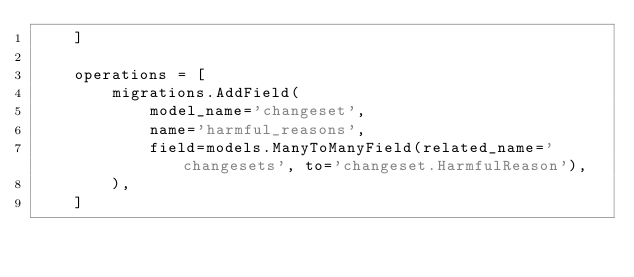Convert code to text. <code><loc_0><loc_0><loc_500><loc_500><_Python_>    ]

    operations = [
        migrations.AddField(
            model_name='changeset',
            name='harmful_reasons',
            field=models.ManyToManyField(related_name='changesets', to='changeset.HarmfulReason'),
        ),
    ]
</code> 